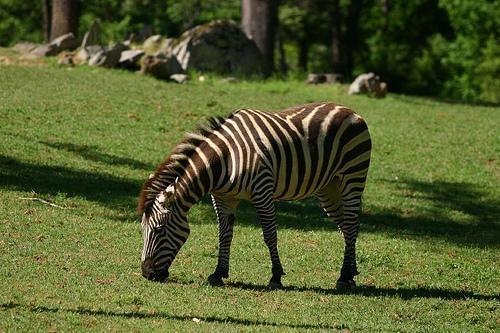How many zebras are there?
Give a very brief answer. 1. 